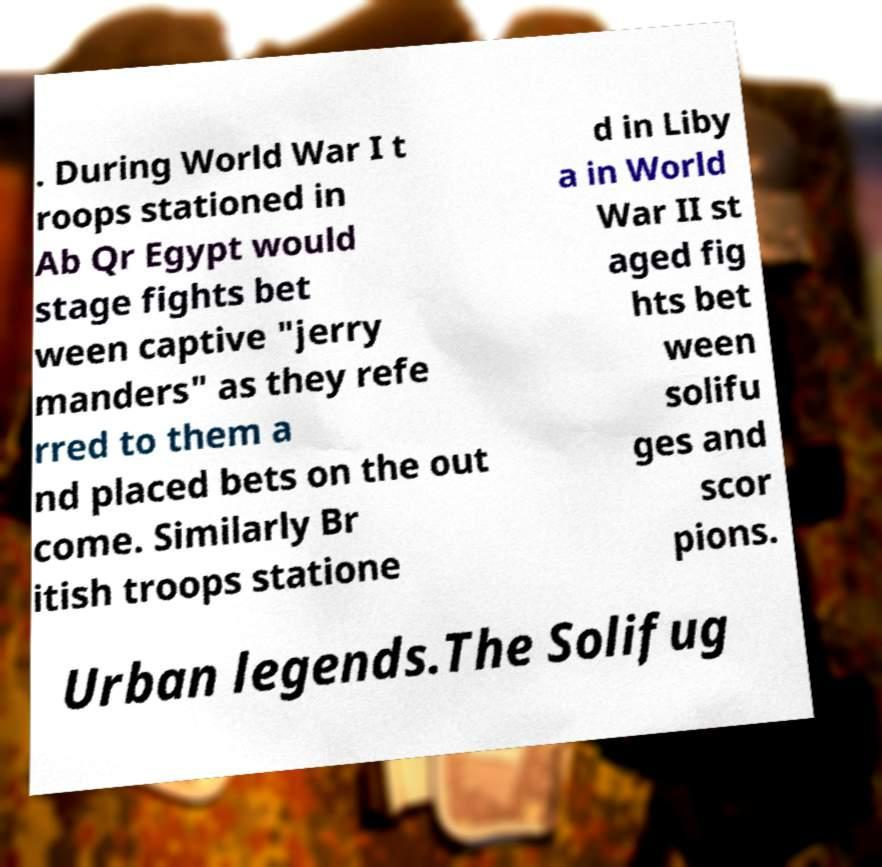There's text embedded in this image that I need extracted. Can you transcribe it verbatim? . During World War I t roops stationed in Ab Qr Egypt would stage fights bet ween captive "jerry manders" as they refe rred to them a nd placed bets on the out come. Similarly Br itish troops statione d in Liby a in World War II st aged fig hts bet ween solifu ges and scor pions. Urban legends.The Solifug 